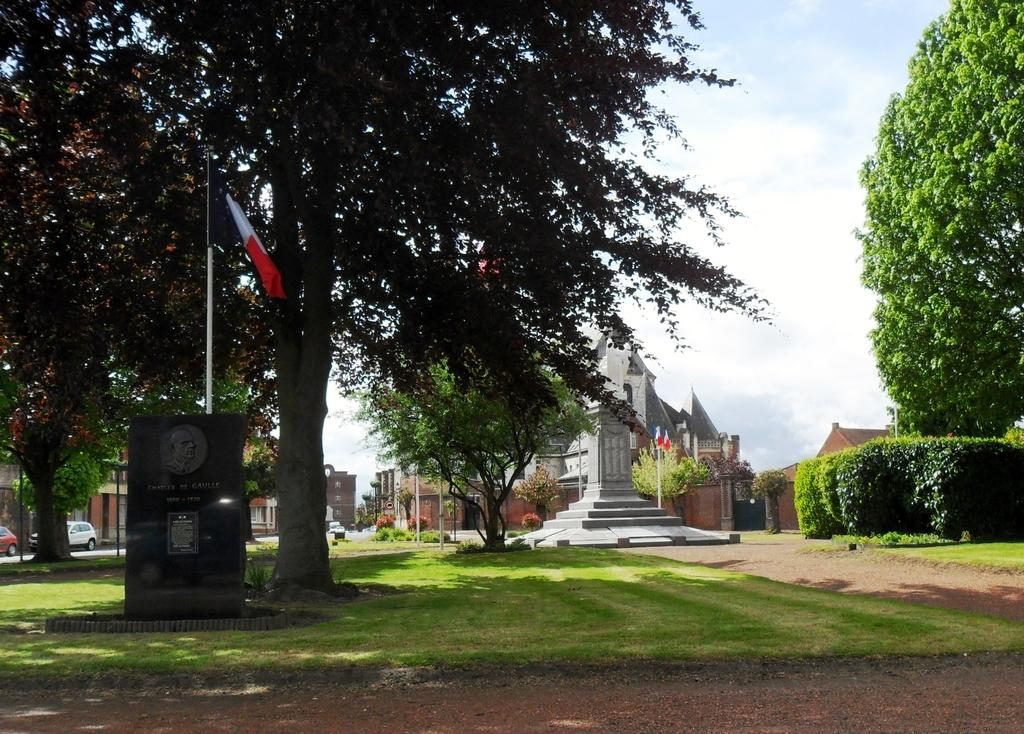What type of vegetation can be seen in the image? There are trees and plants in the image. What structures are present in the image? There are poles, flags, cars, buildings, and a memorial in the image. What type of ground surface is visible in the image? There is grass in the image. What is visible in the background of the image? The sky is visible in the background of the image. What is the governor doing in the image? There is no governor present in the image. How does the grip of the car affect its performance in the image? There are no cars with a grip mentioned in the image, and the performance of the cars is not discussed. 